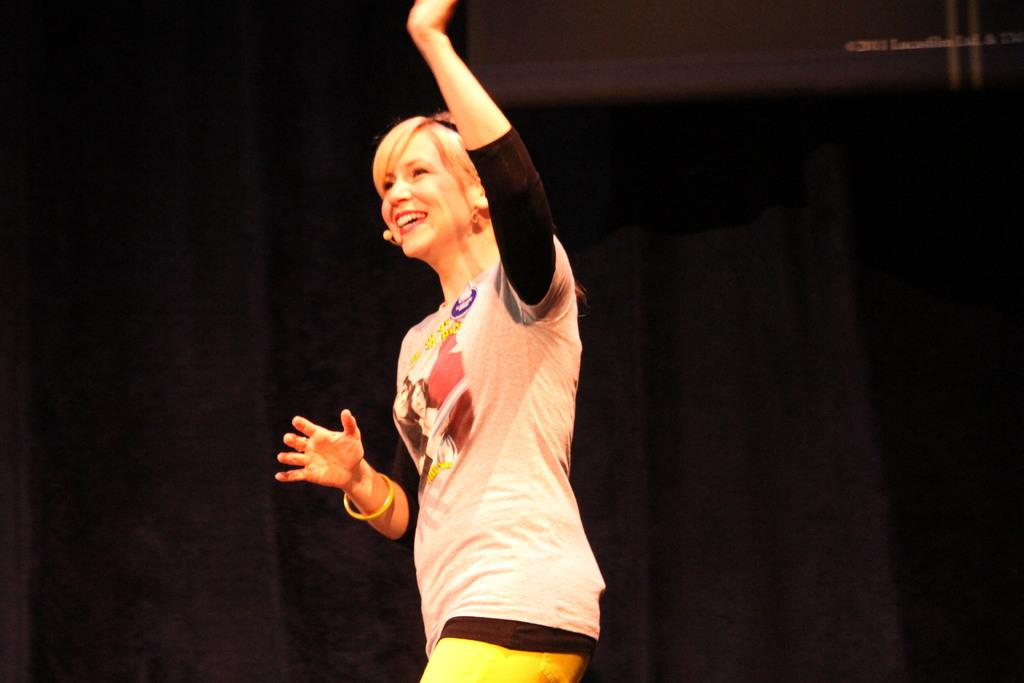What is the main subject of the image? The main subject of the image is a lady standing. Can you describe the background of the image? There is a black curtain in the background of the image. What type of soup is the lady holding in the image? There is no soup present in the image; the lady is simply standing. 